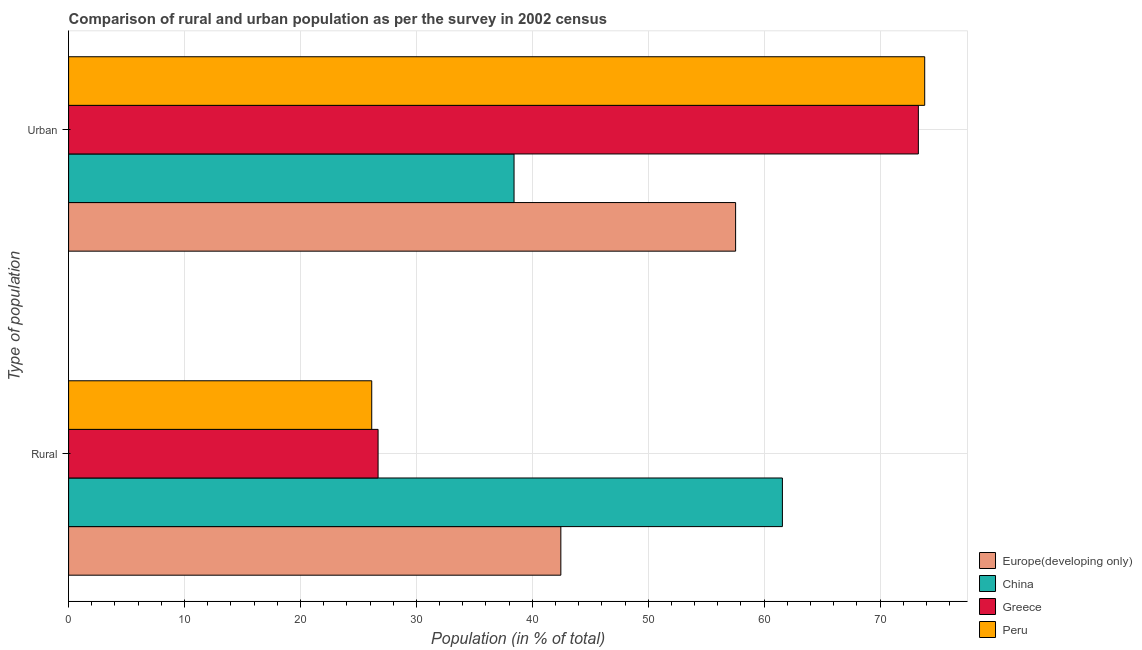How many different coloured bars are there?
Make the answer very short. 4. Are the number of bars on each tick of the Y-axis equal?
Provide a succinct answer. Yes. How many bars are there on the 2nd tick from the top?
Ensure brevity in your answer.  4. How many bars are there on the 2nd tick from the bottom?
Give a very brief answer. 4. What is the label of the 1st group of bars from the top?
Offer a very short reply. Urban. What is the rural population in Peru?
Offer a terse response. 26.15. Across all countries, what is the maximum rural population?
Offer a very short reply. 61.58. Across all countries, what is the minimum urban population?
Provide a short and direct response. 38.42. What is the total urban population in the graph?
Keep it short and to the point. 243.12. What is the difference between the rural population in Peru and that in China?
Your answer should be compact. -35.43. What is the difference between the urban population in Greece and the rural population in Europe(developing only)?
Ensure brevity in your answer.  30.84. What is the average urban population per country?
Keep it short and to the point. 60.78. What is the difference between the urban population and rural population in Greece?
Ensure brevity in your answer.  46.61. What is the ratio of the urban population in China to that in Europe(developing only)?
Your answer should be compact. 0.67. Is the rural population in China less than that in Greece?
Offer a terse response. No. What does the 4th bar from the top in Urban represents?
Give a very brief answer. Europe(developing only). What does the 3rd bar from the bottom in Urban represents?
Give a very brief answer. Greece. How many countries are there in the graph?
Offer a very short reply. 4. Are the values on the major ticks of X-axis written in scientific E-notation?
Your answer should be very brief. No. Does the graph contain grids?
Offer a terse response. Yes. How are the legend labels stacked?
Your answer should be very brief. Vertical. What is the title of the graph?
Ensure brevity in your answer.  Comparison of rural and urban population as per the survey in 2002 census. Does "Uganda" appear as one of the legend labels in the graph?
Ensure brevity in your answer.  No. What is the label or title of the X-axis?
Offer a terse response. Population (in % of total). What is the label or title of the Y-axis?
Your answer should be compact. Type of population. What is the Population (in % of total) of Europe(developing only) in Rural?
Your response must be concise. 42.46. What is the Population (in % of total) of China in Rural?
Provide a short and direct response. 61.58. What is the Population (in % of total) in Greece in Rural?
Your answer should be very brief. 26.7. What is the Population (in % of total) of Peru in Rural?
Offer a very short reply. 26.15. What is the Population (in % of total) of Europe(developing only) in Urban?
Keep it short and to the point. 57.54. What is the Population (in % of total) of China in Urban?
Ensure brevity in your answer.  38.42. What is the Population (in % of total) of Greece in Urban?
Provide a short and direct response. 73.3. What is the Population (in % of total) of Peru in Urban?
Your response must be concise. 73.85. Across all Type of population, what is the maximum Population (in % of total) in Europe(developing only)?
Your answer should be very brief. 57.54. Across all Type of population, what is the maximum Population (in % of total) of China?
Provide a succinct answer. 61.58. Across all Type of population, what is the maximum Population (in % of total) in Greece?
Make the answer very short. 73.3. Across all Type of population, what is the maximum Population (in % of total) in Peru?
Provide a short and direct response. 73.85. Across all Type of population, what is the minimum Population (in % of total) in Europe(developing only)?
Your response must be concise. 42.46. Across all Type of population, what is the minimum Population (in % of total) in China?
Give a very brief answer. 38.42. Across all Type of population, what is the minimum Population (in % of total) in Greece?
Your answer should be very brief. 26.7. Across all Type of population, what is the minimum Population (in % of total) of Peru?
Make the answer very short. 26.15. What is the difference between the Population (in % of total) of Europe(developing only) in Rural and that in Urban?
Provide a succinct answer. -15.08. What is the difference between the Population (in % of total) of China in Rural and that in Urban?
Provide a short and direct response. 23.15. What is the difference between the Population (in % of total) in Greece in Rural and that in Urban?
Make the answer very short. -46.61. What is the difference between the Population (in % of total) in Peru in Rural and that in Urban?
Your response must be concise. -47.7. What is the difference between the Population (in % of total) of Europe(developing only) in Rural and the Population (in % of total) of China in Urban?
Provide a succinct answer. 4.04. What is the difference between the Population (in % of total) in Europe(developing only) in Rural and the Population (in % of total) in Greece in Urban?
Ensure brevity in your answer.  -30.84. What is the difference between the Population (in % of total) in Europe(developing only) in Rural and the Population (in % of total) in Peru in Urban?
Your answer should be very brief. -31.39. What is the difference between the Population (in % of total) in China in Rural and the Population (in % of total) in Greece in Urban?
Offer a terse response. -11.73. What is the difference between the Population (in % of total) of China in Rural and the Population (in % of total) of Peru in Urban?
Ensure brevity in your answer.  -12.28. What is the difference between the Population (in % of total) of Greece in Rural and the Population (in % of total) of Peru in Urban?
Your answer should be compact. -47.15. What is the average Population (in % of total) in China per Type of population?
Give a very brief answer. 50. What is the average Population (in % of total) in Greece per Type of population?
Your answer should be very brief. 50. What is the average Population (in % of total) in Peru per Type of population?
Keep it short and to the point. 50. What is the difference between the Population (in % of total) in Europe(developing only) and Population (in % of total) in China in Rural?
Make the answer very short. -19.11. What is the difference between the Population (in % of total) of Europe(developing only) and Population (in % of total) of Greece in Rural?
Your answer should be compact. 15.77. What is the difference between the Population (in % of total) of Europe(developing only) and Population (in % of total) of Peru in Rural?
Keep it short and to the point. 16.31. What is the difference between the Population (in % of total) in China and Population (in % of total) in Greece in Rural?
Your answer should be very brief. 34.88. What is the difference between the Population (in % of total) of China and Population (in % of total) of Peru in Rural?
Provide a succinct answer. 35.42. What is the difference between the Population (in % of total) of Greece and Population (in % of total) of Peru in Rural?
Offer a terse response. 0.55. What is the difference between the Population (in % of total) of Europe(developing only) and Population (in % of total) of China in Urban?
Give a very brief answer. 19.11. What is the difference between the Population (in % of total) in Europe(developing only) and Population (in % of total) in Greece in Urban?
Keep it short and to the point. -15.77. What is the difference between the Population (in % of total) of Europe(developing only) and Population (in % of total) of Peru in Urban?
Give a very brief answer. -16.31. What is the difference between the Population (in % of total) in China and Population (in % of total) in Greece in Urban?
Provide a short and direct response. -34.88. What is the difference between the Population (in % of total) of China and Population (in % of total) of Peru in Urban?
Offer a very short reply. -35.42. What is the difference between the Population (in % of total) of Greece and Population (in % of total) of Peru in Urban?
Make the answer very short. -0.55. What is the ratio of the Population (in % of total) in Europe(developing only) in Rural to that in Urban?
Provide a short and direct response. 0.74. What is the ratio of the Population (in % of total) of China in Rural to that in Urban?
Offer a very short reply. 1.6. What is the ratio of the Population (in % of total) in Greece in Rural to that in Urban?
Ensure brevity in your answer.  0.36. What is the ratio of the Population (in % of total) in Peru in Rural to that in Urban?
Offer a very short reply. 0.35. What is the difference between the highest and the second highest Population (in % of total) of Europe(developing only)?
Offer a terse response. 15.08. What is the difference between the highest and the second highest Population (in % of total) of China?
Make the answer very short. 23.15. What is the difference between the highest and the second highest Population (in % of total) of Greece?
Ensure brevity in your answer.  46.61. What is the difference between the highest and the second highest Population (in % of total) in Peru?
Make the answer very short. 47.7. What is the difference between the highest and the lowest Population (in % of total) of Europe(developing only)?
Give a very brief answer. 15.08. What is the difference between the highest and the lowest Population (in % of total) of China?
Offer a terse response. 23.15. What is the difference between the highest and the lowest Population (in % of total) of Greece?
Your answer should be very brief. 46.61. What is the difference between the highest and the lowest Population (in % of total) in Peru?
Provide a succinct answer. 47.7. 